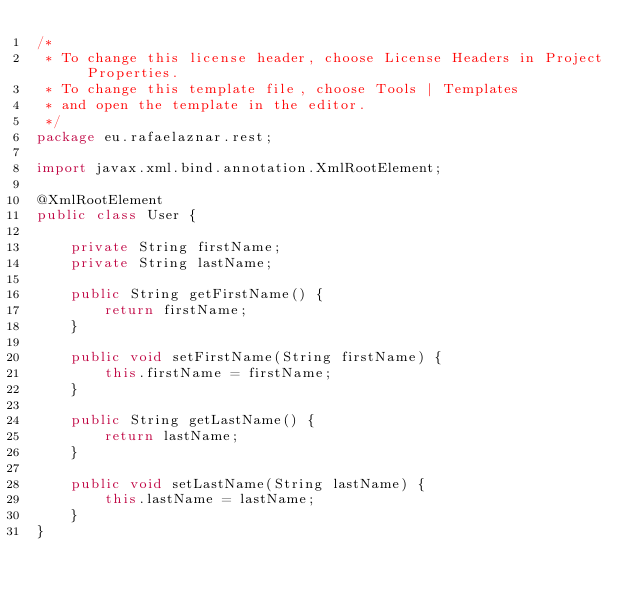<code> <loc_0><loc_0><loc_500><loc_500><_Java_>/*
 * To change this license header, choose License Headers in Project Properties.
 * To change this template file, choose Tools | Templates
 * and open the template in the editor.
 */
package eu.rafaelaznar.rest;

import javax.xml.bind.annotation.XmlRootElement;

@XmlRootElement
public class User {

    private String firstName;
    private String lastName;

    public String getFirstName() {
        return firstName;
    }

    public void setFirstName(String firstName) {
        this.firstName = firstName;
    }

    public String getLastName() {
        return lastName;
    }

    public void setLastName(String lastName) {
        this.lastName = lastName;
    }
}
</code> 